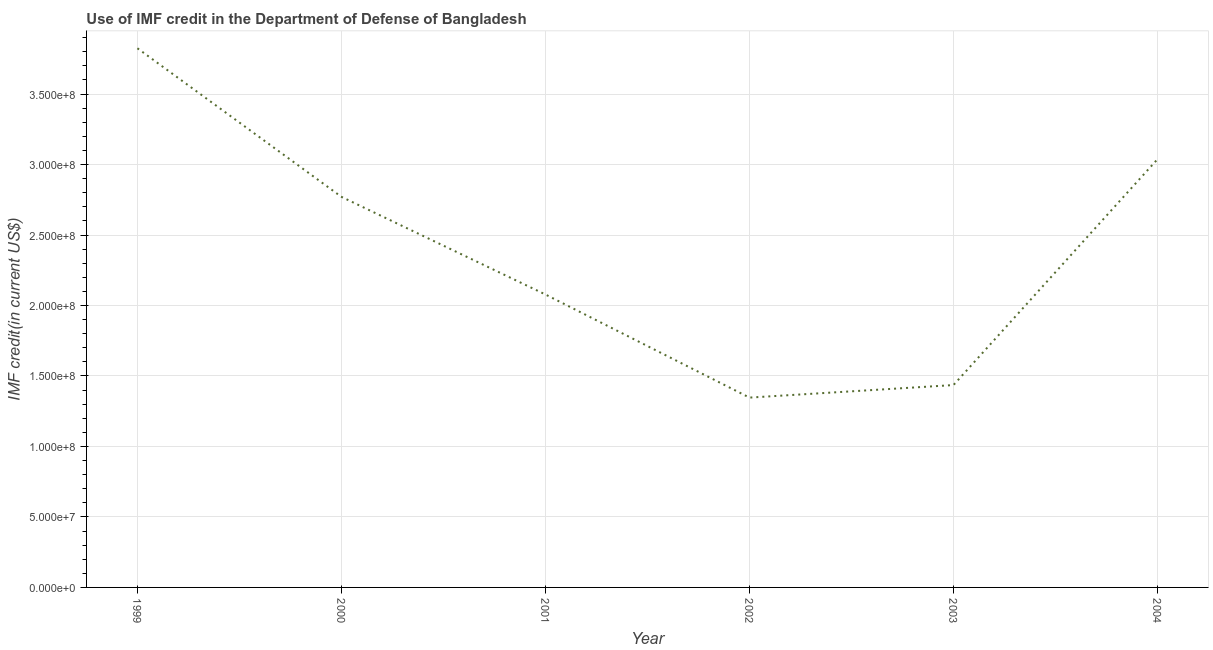What is the use of imf credit in dod in 2004?
Your answer should be compact. 3.04e+08. Across all years, what is the maximum use of imf credit in dod?
Ensure brevity in your answer.  3.82e+08. Across all years, what is the minimum use of imf credit in dod?
Provide a succinct answer. 1.35e+08. In which year was the use of imf credit in dod maximum?
Offer a very short reply. 1999. In which year was the use of imf credit in dod minimum?
Make the answer very short. 2002. What is the sum of the use of imf credit in dod?
Offer a terse response. 1.45e+09. What is the difference between the use of imf credit in dod in 2001 and 2003?
Your answer should be very brief. 6.43e+07. What is the average use of imf credit in dod per year?
Provide a succinct answer. 2.42e+08. What is the median use of imf credit in dod?
Give a very brief answer. 2.42e+08. In how many years, is the use of imf credit in dod greater than 70000000 US$?
Keep it short and to the point. 6. Do a majority of the years between 2003 and 2002 (inclusive) have use of imf credit in dod greater than 80000000 US$?
Your answer should be very brief. No. What is the ratio of the use of imf credit in dod in 2001 to that in 2003?
Keep it short and to the point. 1.45. Is the difference between the use of imf credit in dod in 1999 and 2000 greater than the difference between any two years?
Your answer should be compact. No. What is the difference between the highest and the second highest use of imf credit in dod?
Offer a terse response. 7.87e+07. What is the difference between the highest and the lowest use of imf credit in dod?
Your answer should be compact. 2.48e+08. In how many years, is the use of imf credit in dod greater than the average use of imf credit in dod taken over all years?
Give a very brief answer. 3. How many lines are there?
Your answer should be compact. 1. How many years are there in the graph?
Make the answer very short. 6. What is the difference between two consecutive major ticks on the Y-axis?
Your answer should be very brief. 5.00e+07. What is the title of the graph?
Provide a succinct answer. Use of IMF credit in the Department of Defense of Bangladesh. What is the label or title of the X-axis?
Provide a succinct answer. Year. What is the label or title of the Y-axis?
Your answer should be very brief. IMF credit(in current US$). What is the IMF credit(in current US$) in 1999?
Make the answer very short. 3.82e+08. What is the IMF credit(in current US$) in 2000?
Your answer should be very brief. 2.77e+08. What is the IMF credit(in current US$) in 2001?
Make the answer very short. 2.08e+08. What is the IMF credit(in current US$) in 2002?
Your answer should be very brief. 1.35e+08. What is the IMF credit(in current US$) of 2003?
Keep it short and to the point. 1.44e+08. What is the IMF credit(in current US$) in 2004?
Provide a succinct answer. 3.04e+08. What is the difference between the IMF credit(in current US$) in 1999 and 2000?
Your answer should be very brief. 1.05e+08. What is the difference between the IMF credit(in current US$) in 1999 and 2001?
Your answer should be compact. 1.75e+08. What is the difference between the IMF credit(in current US$) in 1999 and 2002?
Provide a succinct answer. 2.48e+08. What is the difference between the IMF credit(in current US$) in 1999 and 2003?
Give a very brief answer. 2.39e+08. What is the difference between the IMF credit(in current US$) in 1999 and 2004?
Offer a terse response. 7.87e+07. What is the difference between the IMF credit(in current US$) in 2000 and 2001?
Your answer should be very brief. 6.93e+07. What is the difference between the IMF credit(in current US$) in 2000 and 2002?
Your response must be concise. 1.42e+08. What is the difference between the IMF credit(in current US$) in 2000 and 2003?
Provide a succinct answer. 1.34e+08. What is the difference between the IMF credit(in current US$) in 2000 and 2004?
Give a very brief answer. -2.67e+07. What is the difference between the IMF credit(in current US$) in 2001 and 2002?
Provide a succinct answer. 7.32e+07. What is the difference between the IMF credit(in current US$) in 2001 and 2003?
Give a very brief answer. 6.43e+07. What is the difference between the IMF credit(in current US$) in 2001 and 2004?
Give a very brief answer. -9.60e+07. What is the difference between the IMF credit(in current US$) in 2002 and 2003?
Ensure brevity in your answer.  -8.90e+06. What is the difference between the IMF credit(in current US$) in 2002 and 2004?
Make the answer very short. -1.69e+08. What is the difference between the IMF credit(in current US$) in 2003 and 2004?
Ensure brevity in your answer.  -1.60e+08. What is the ratio of the IMF credit(in current US$) in 1999 to that in 2000?
Provide a short and direct response. 1.38. What is the ratio of the IMF credit(in current US$) in 1999 to that in 2001?
Your answer should be compact. 1.84. What is the ratio of the IMF credit(in current US$) in 1999 to that in 2002?
Make the answer very short. 2.84. What is the ratio of the IMF credit(in current US$) in 1999 to that in 2003?
Make the answer very short. 2.66. What is the ratio of the IMF credit(in current US$) in 1999 to that in 2004?
Provide a succinct answer. 1.26. What is the ratio of the IMF credit(in current US$) in 2000 to that in 2001?
Keep it short and to the point. 1.33. What is the ratio of the IMF credit(in current US$) in 2000 to that in 2002?
Ensure brevity in your answer.  2.06. What is the ratio of the IMF credit(in current US$) in 2000 to that in 2003?
Provide a succinct answer. 1.93. What is the ratio of the IMF credit(in current US$) in 2000 to that in 2004?
Your response must be concise. 0.91. What is the ratio of the IMF credit(in current US$) in 2001 to that in 2002?
Keep it short and to the point. 1.54. What is the ratio of the IMF credit(in current US$) in 2001 to that in 2003?
Provide a short and direct response. 1.45. What is the ratio of the IMF credit(in current US$) in 2001 to that in 2004?
Your response must be concise. 0.68. What is the ratio of the IMF credit(in current US$) in 2002 to that in 2003?
Make the answer very short. 0.94. What is the ratio of the IMF credit(in current US$) in 2002 to that in 2004?
Your response must be concise. 0.44. What is the ratio of the IMF credit(in current US$) in 2003 to that in 2004?
Your answer should be compact. 0.47. 